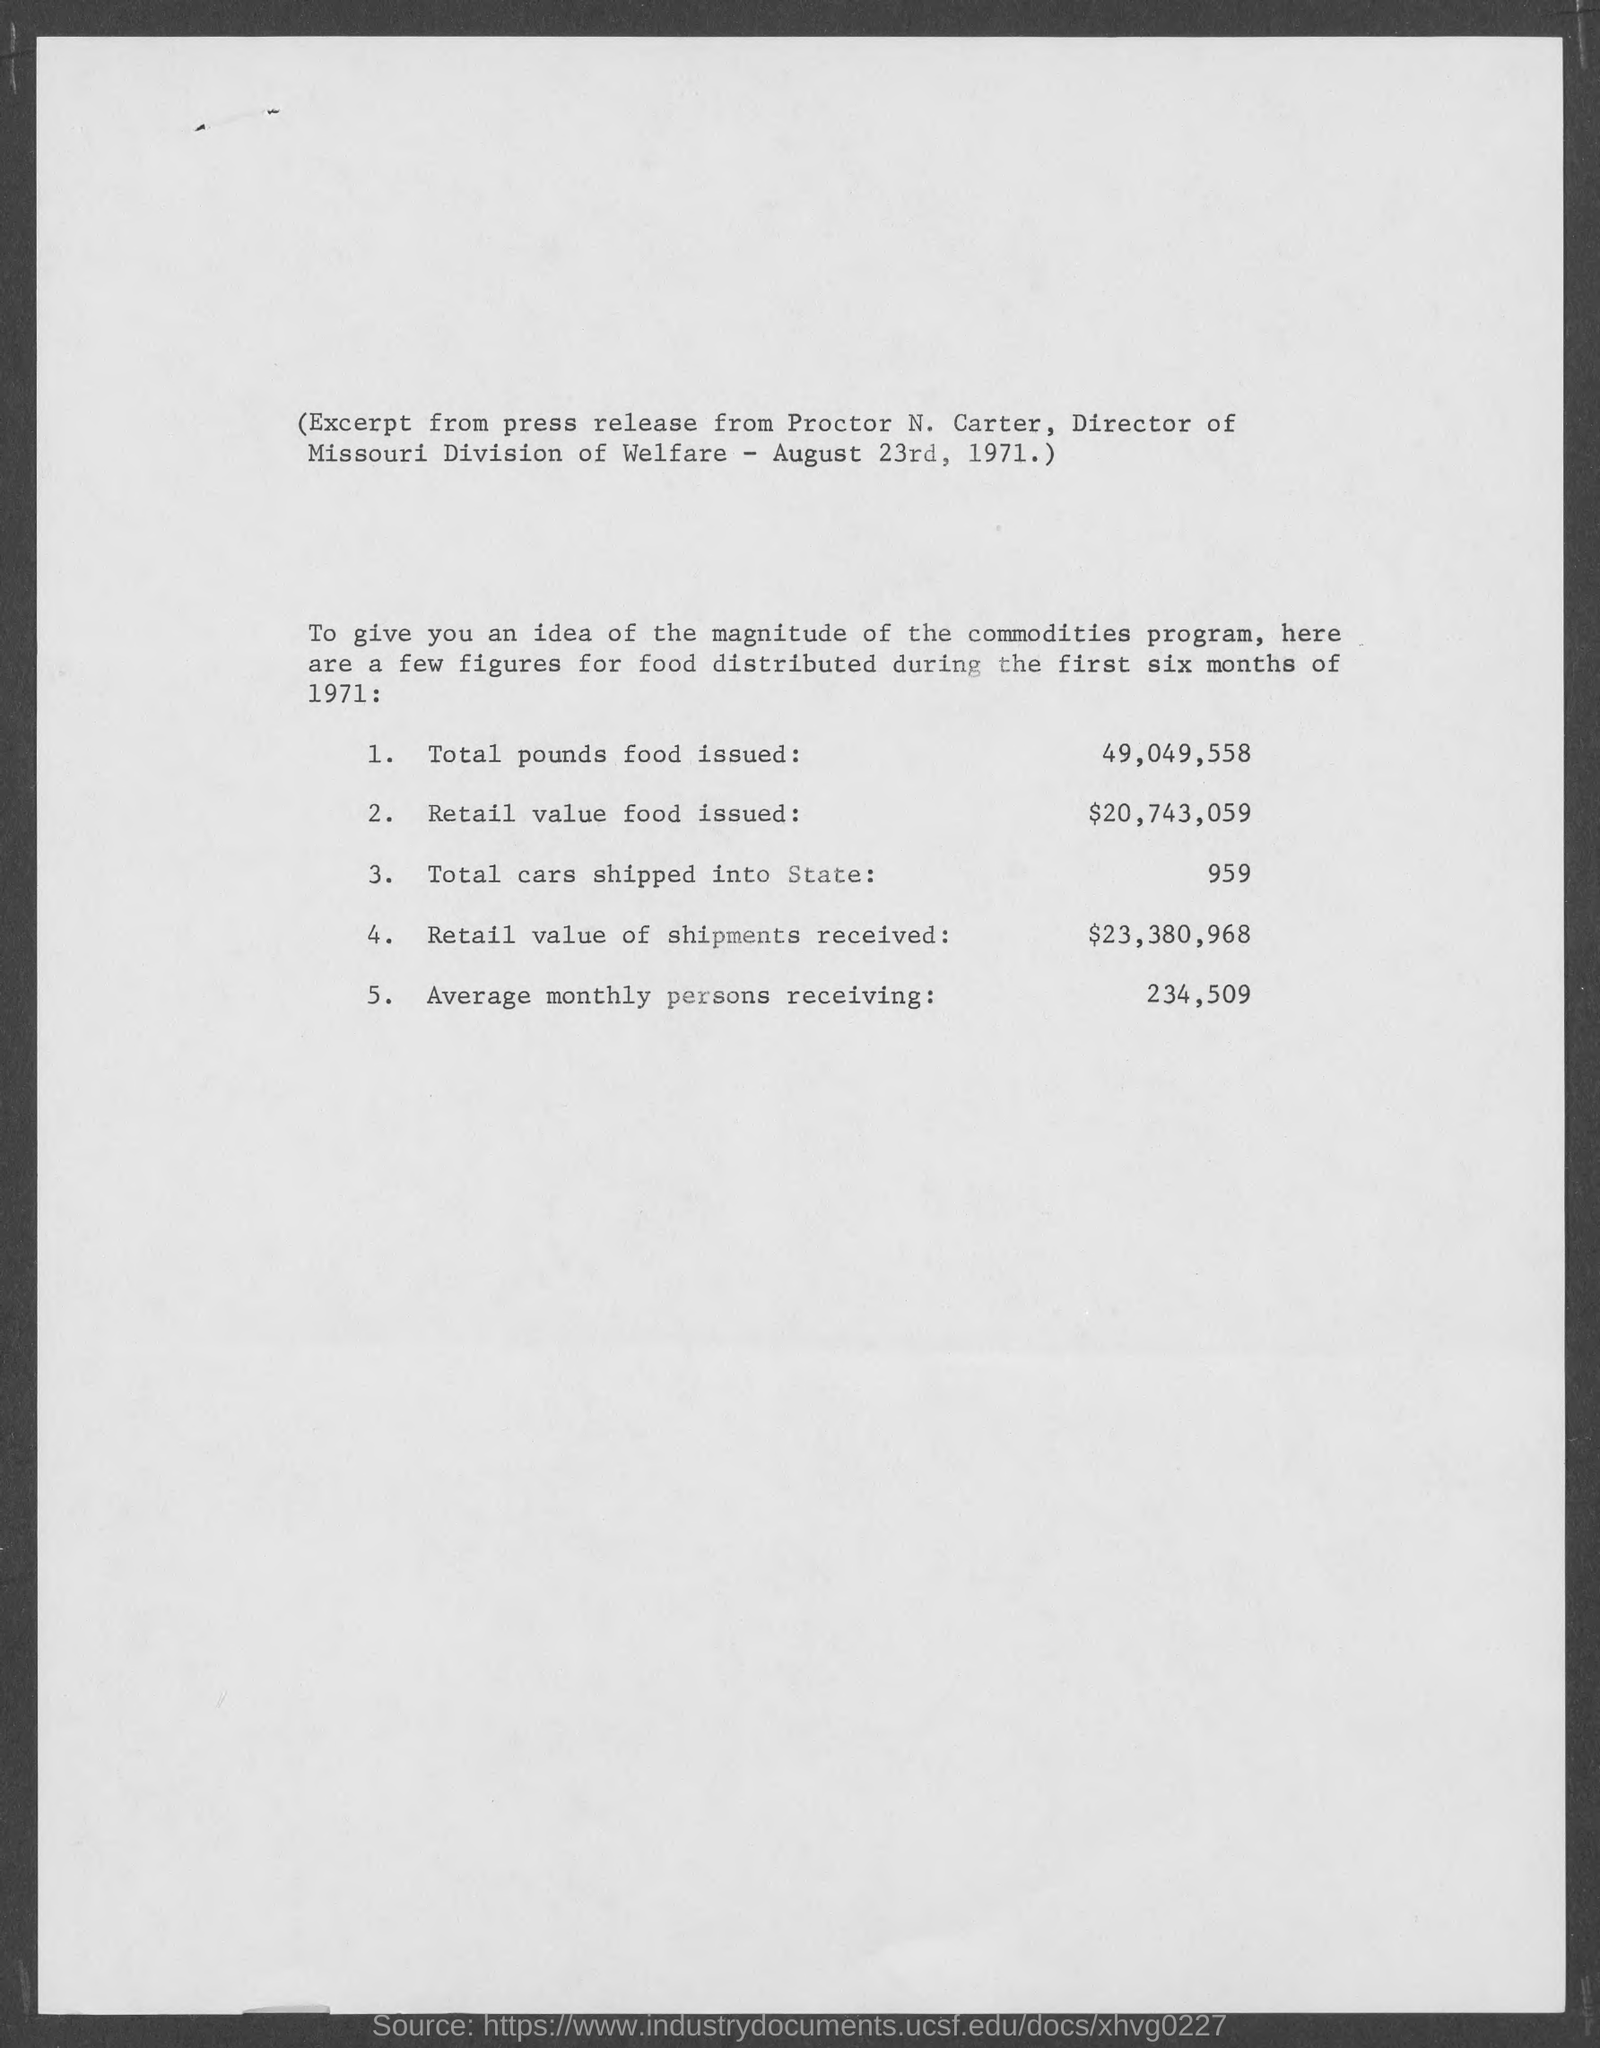What are the Total pounds food issued?
Ensure brevity in your answer.  49,049,558. What are Retail value food issued?
Offer a terse response. $20,743,059. What is the total cars shipped into state?
Provide a short and direct response. 959. What is the retail value of shipments received?
Your answer should be very brief. $23,380,968. What is the average monthly persons receiving?
Ensure brevity in your answer.  234,509. What is the date on the document?
Your response must be concise. August 23rd, 1971. 